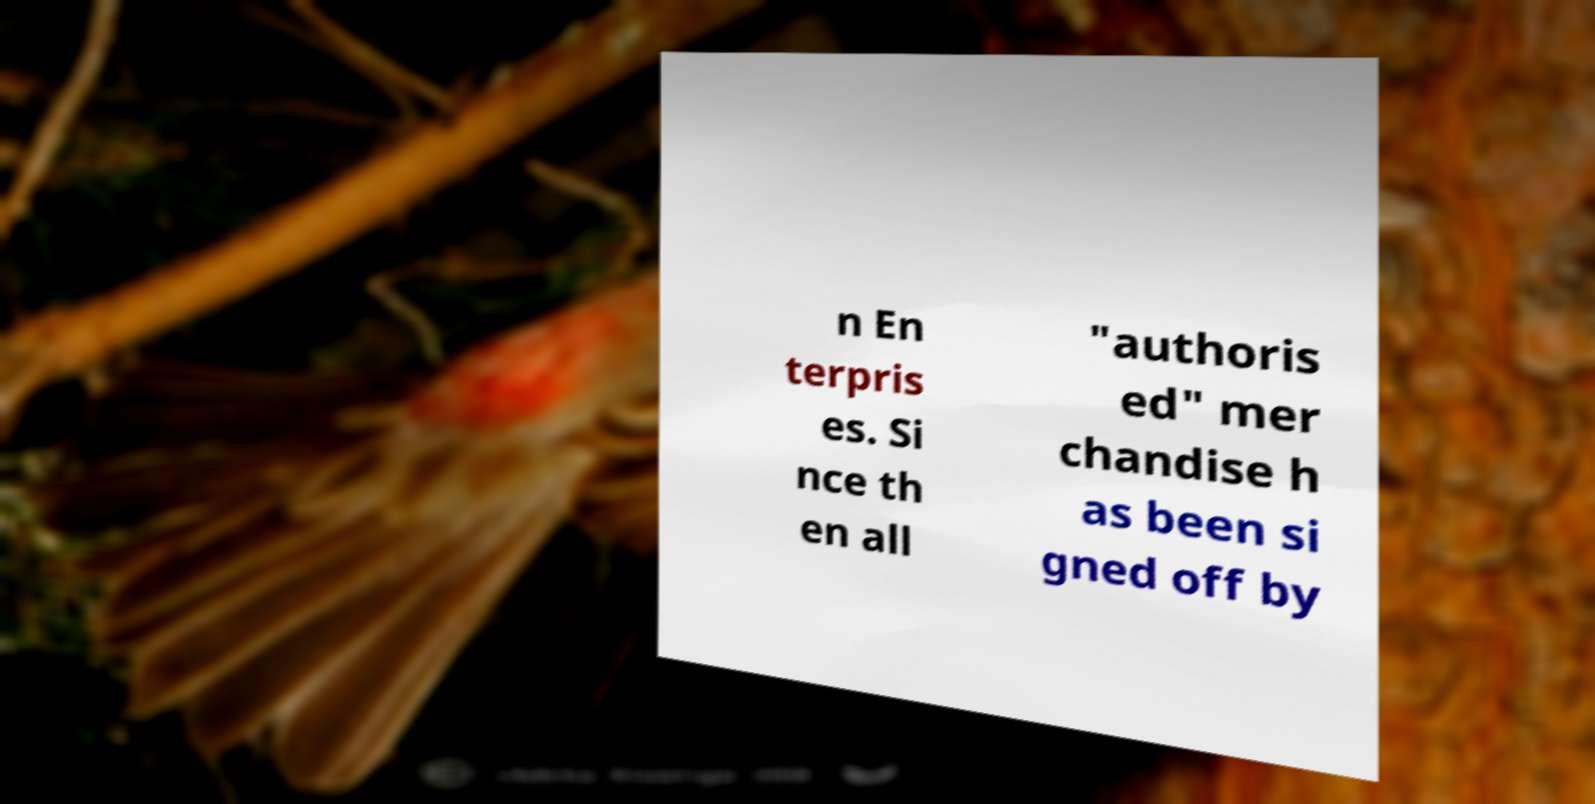Please read and relay the text visible in this image. What does it say? n En terpris es. Si nce th en all "authoris ed" mer chandise h as been si gned off by 